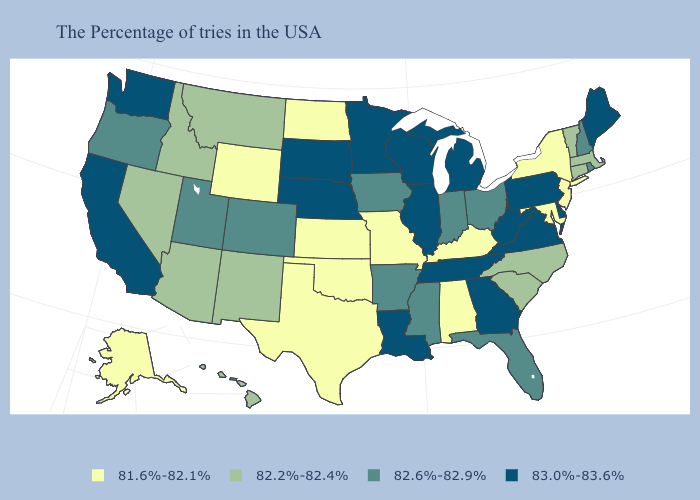What is the value of Colorado?
Quick response, please. 82.6%-82.9%. Does Louisiana have the highest value in the South?
Keep it brief. Yes. What is the highest value in states that border Kansas?
Keep it brief. 83.0%-83.6%. Name the states that have a value in the range 82.6%-82.9%?
Be succinct. Rhode Island, New Hampshire, Ohio, Florida, Indiana, Mississippi, Arkansas, Iowa, Colorado, Utah, Oregon. Does the first symbol in the legend represent the smallest category?
Write a very short answer. Yes. Which states have the lowest value in the Northeast?
Write a very short answer. New York, New Jersey. What is the value of Virginia?
Answer briefly. 83.0%-83.6%. What is the value of Louisiana?
Be succinct. 83.0%-83.6%. Does West Virginia have the highest value in the South?
Concise answer only. Yes. How many symbols are there in the legend?
Be succinct. 4. What is the value of Maryland?
Write a very short answer. 81.6%-82.1%. What is the value of Montana?
Keep it brief. 82.2%-82.4%. Does Wyoming have a lower value than Texas?
Keep it brief. No. What is the highest value in the Northeast ?
Write a very short answer. 83.0%-83.6%. 